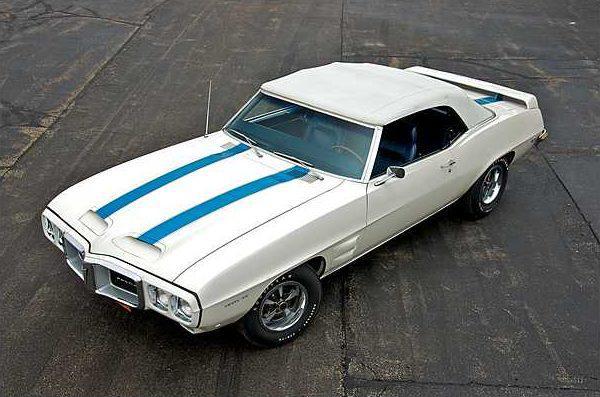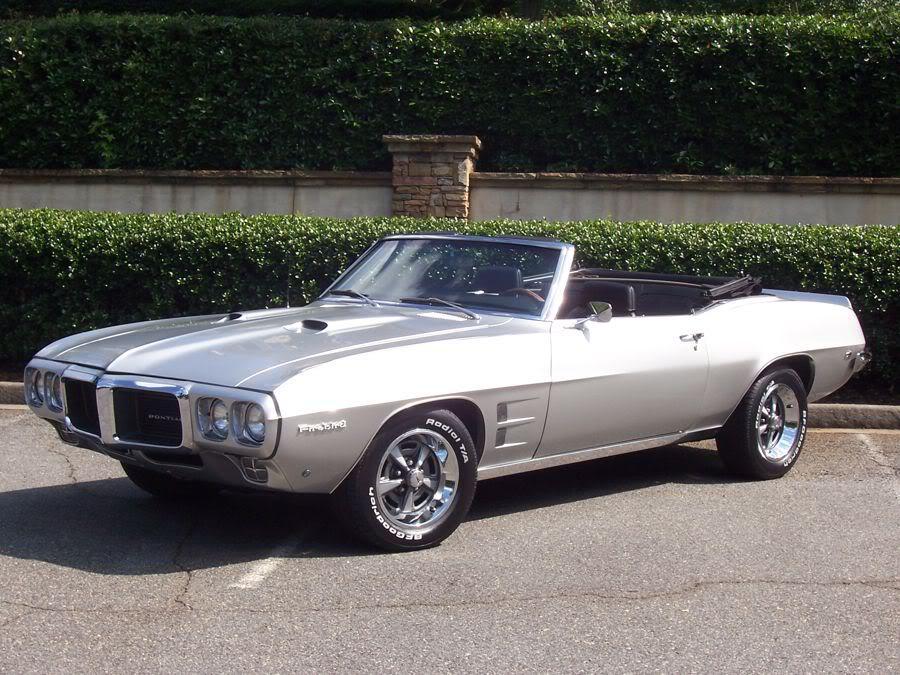The first image is the image on the left, the second image is the image on the right. Examine the images to the left and right. Is the description "Two cars are facing left." accurate? Answer yes or no. Yes. 